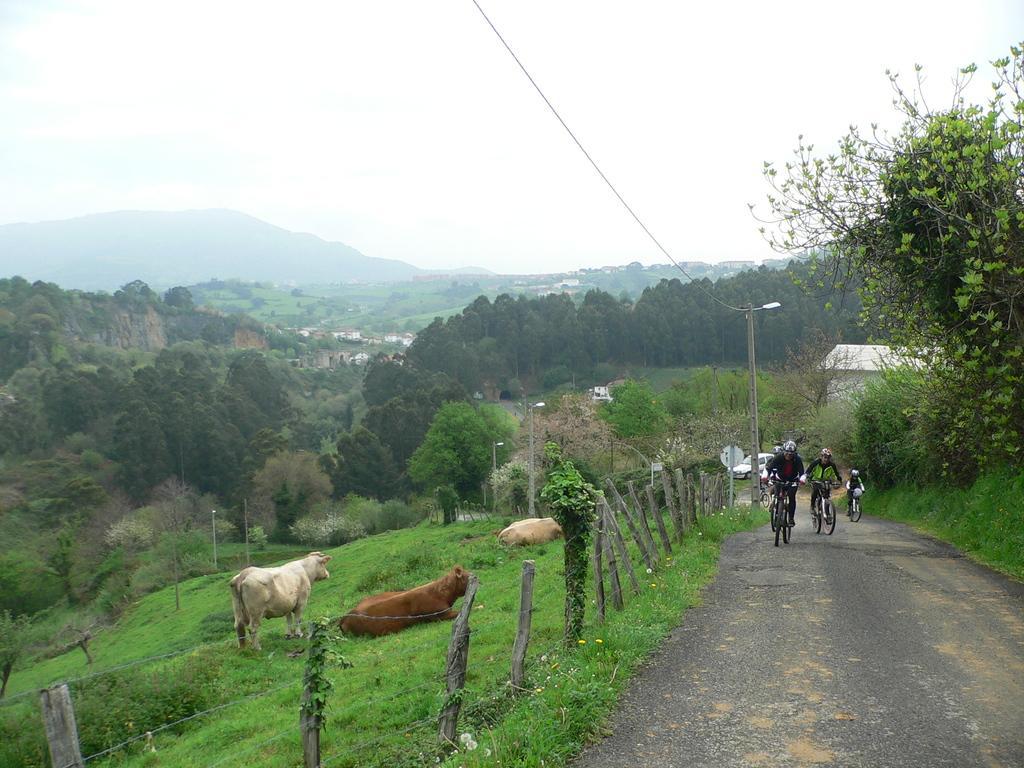Can you describe this image briefly? In the background we can see sky, hills and trees. On either side of the road we can see grass. This is a fence. Here we can see animals and people riding bicycles on the road. Here we can see lights with poles. 